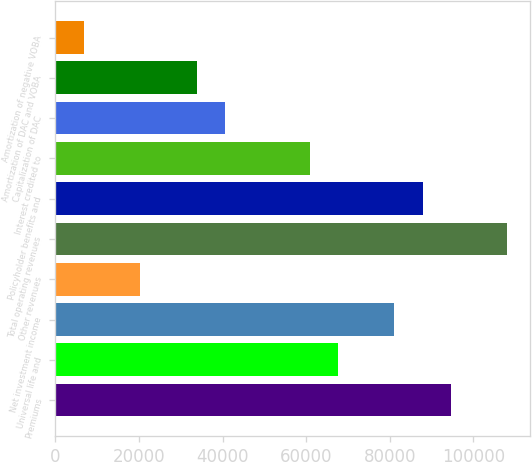<chart> <loc_0><loc_0><loc_500><loc_500><bar_chart><fcel>Premiums<fcel>Universal life and<fcel>Net investment income<fcel>Other revenues<fcel>Total operating revenues<fcel>Policyholder benefits and<fcel>Interest credited to<fcel>Capitalization of DAC<fcel>Amortization of DAC and VOBA<fcel>Amortization of negative VOBA<nl><fcel>94605.2<fcel>67610<fcel>81107.6<fcel>20368.4<fcel>108103<fcel>87856.4<fcel>60861.2<fcel>40614.8<fcel>33866<fcel>6870.8<nl></chart> 